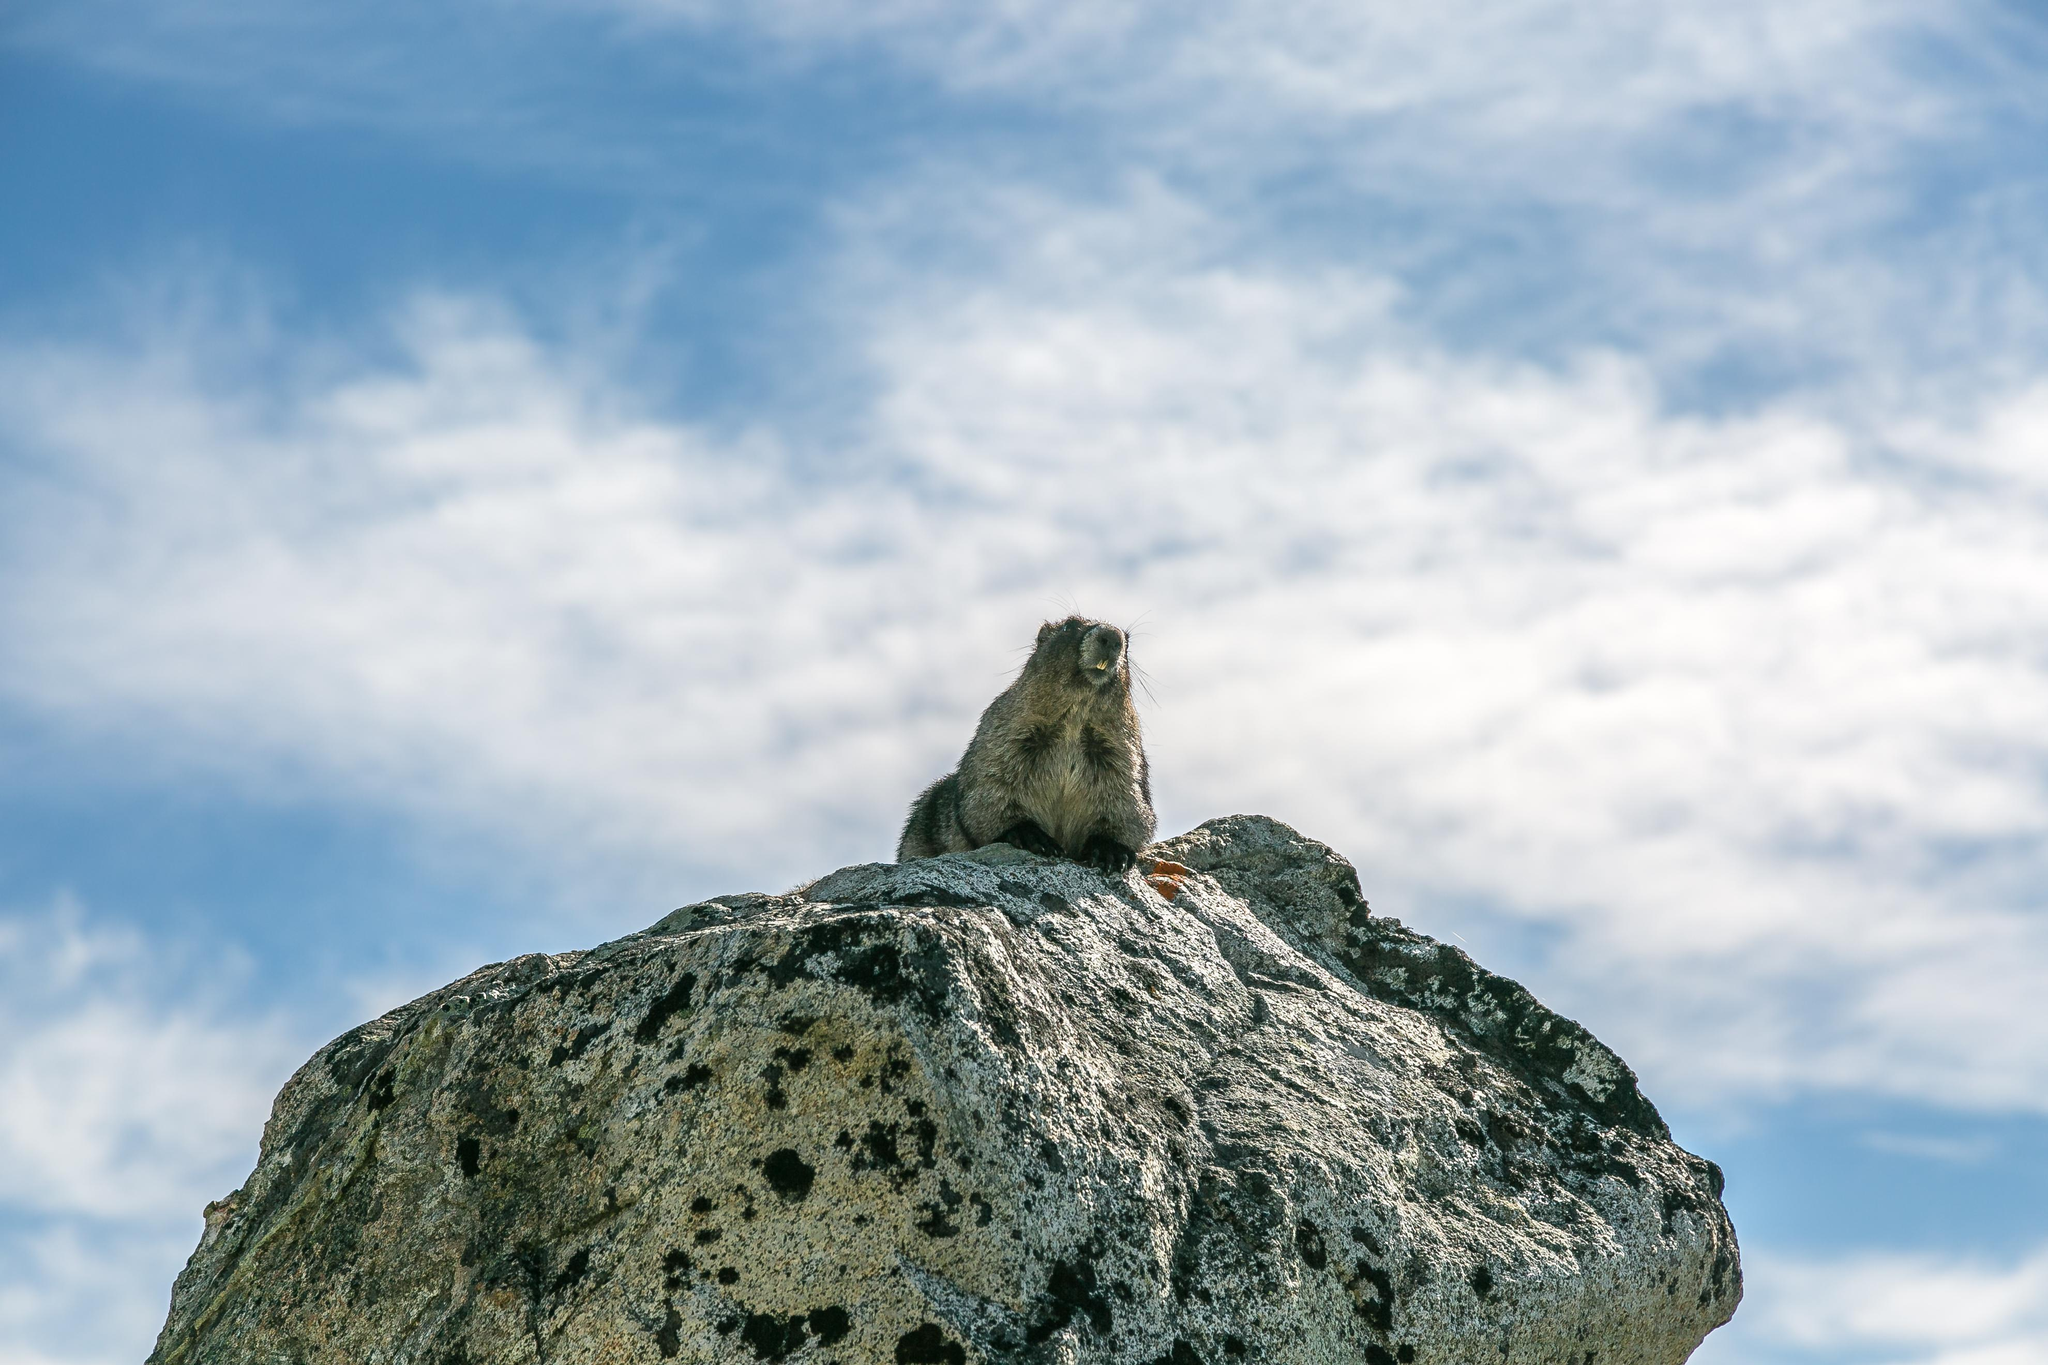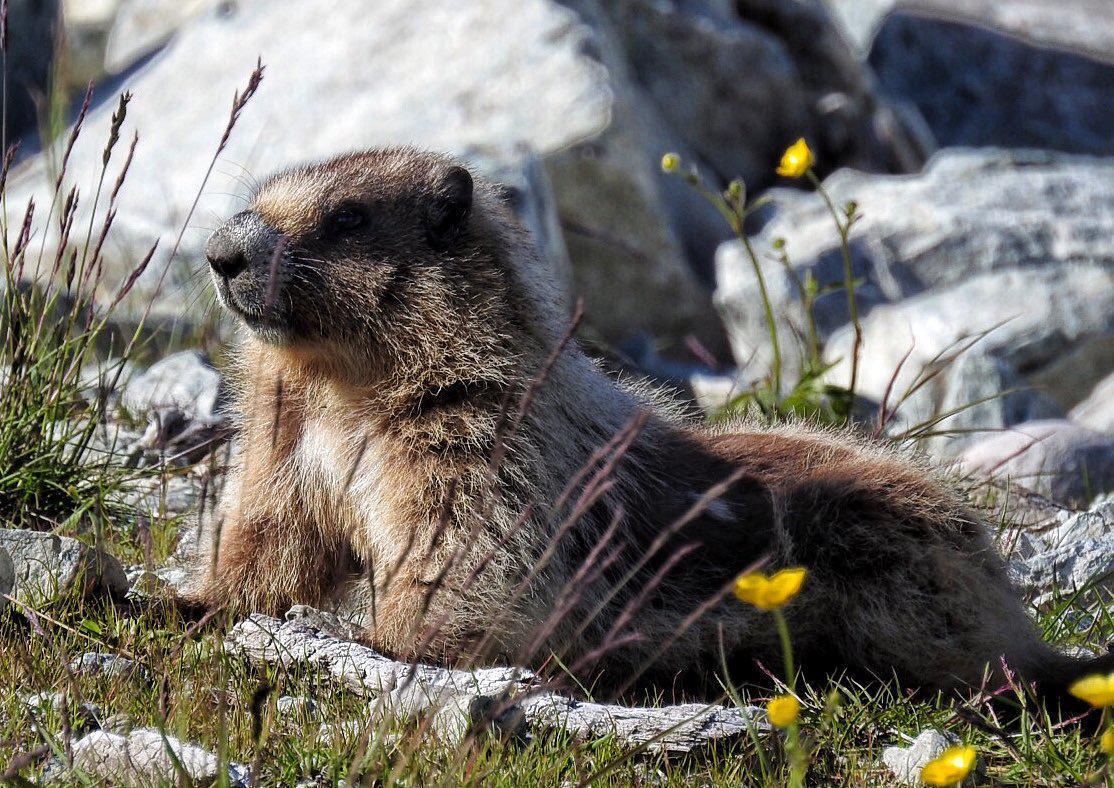The first image is the image on the left, the second image is the image on the right. Analyze the images presented: Is the assertion "There are two ground hogs perched high on a rock." valid? Answer yes or no. No. The first image is the image on the left, the second image is the image on the right. Examine the images to the left and right. Is the description "One of the groundhogs is near yellow flowers." accurate? Answer yes or no. Yes. 